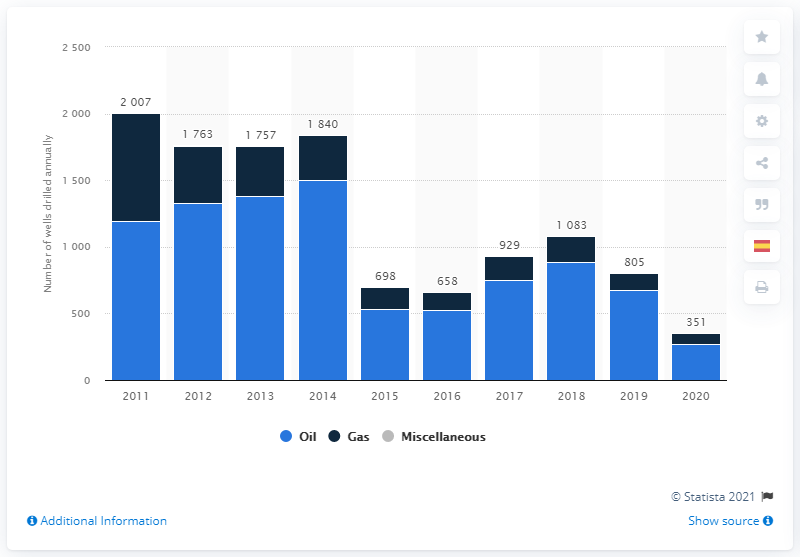Highlight a few significant elements in this photo. At the end of 2020, there were 83 gas rigs in the United States. There were 267 active rotary oil rigs at the end of 2020. 